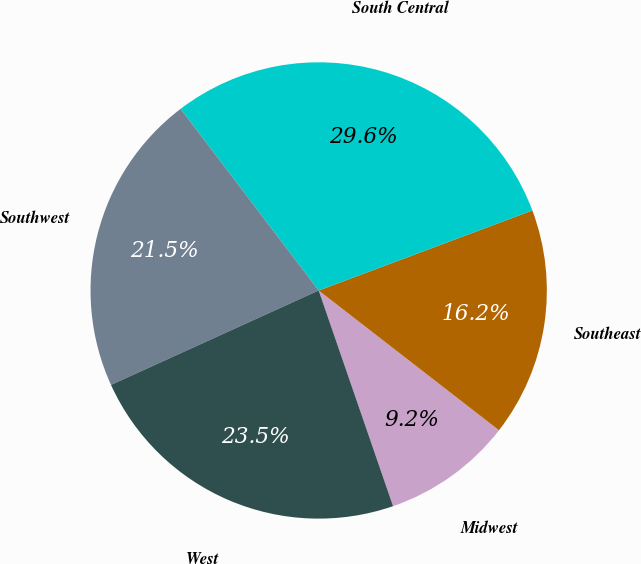Convert chart to OTSL. <chart><loc_0><loc_0><loc_500><loc_500><pie_chart><fcel>Midwest<fcel>Southeast<fcel>South Central<fcel>Southwest<fcel>West<nl><fcel>9.22%<fcel>16.2%<fcel>29.64%<fcel>21.45%<fcel>23.49%<nl></chart> 